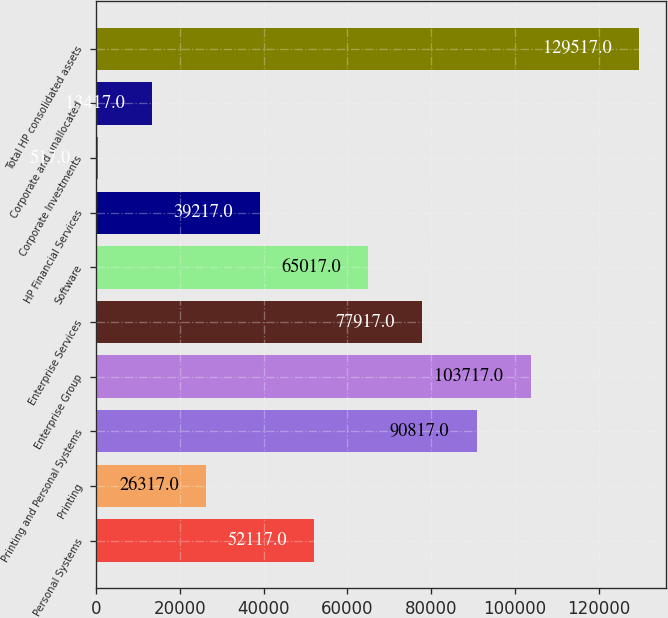Convert chart. <chart><loc_0><loc_0><loc_500><loc_500><bar_chart><fcel>Personal Systems<fcel>Printing<fcel>Printing and Personal Systems<fcel>Enterprise Group<fcel>Enterprise Services<fcel>Software<fcel>HP Financial Services<fcel>Corporate Investments<fcel>Corporate and unallocated<fcel>Total HP consolidated assets<nl><fcel>52117<fcel>26317<fcel>90817<fcel>103717<fcel>77917<fcel>65017<fcel>39217<fcel>517<fcel>13417<fcel>129517<nl></chart> 